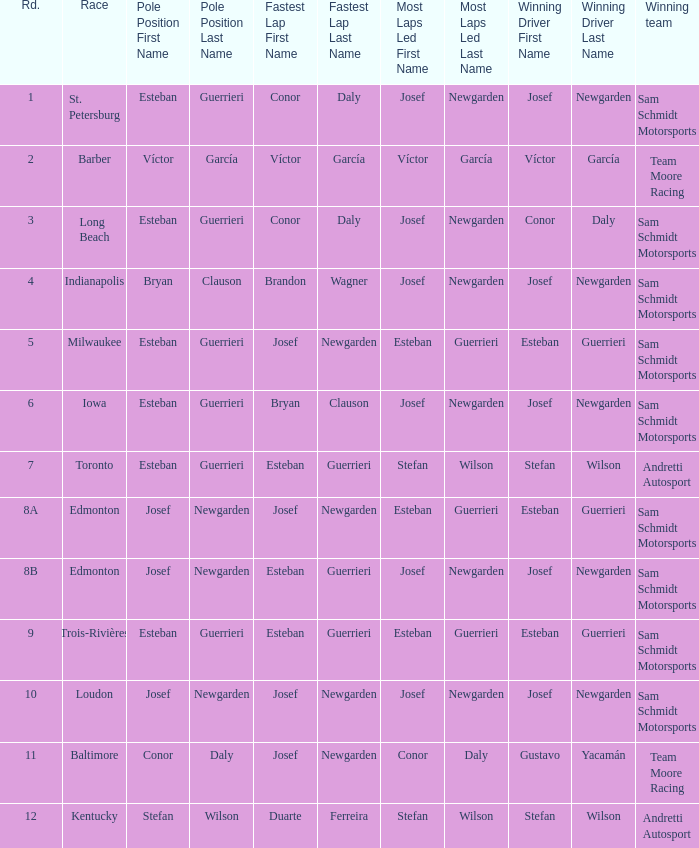Who had the pole(s) when esteban guerrieri led the most laps round 8a and josef newgarden had the fastest lap? Josef Newgarden. 